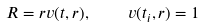Convert formula to latex. <formula><loc_0><loc_0><loc_500><loc_500>R = r v ( t , r ) , \quad v ( t _ { i } , r ) = 1</formula> 